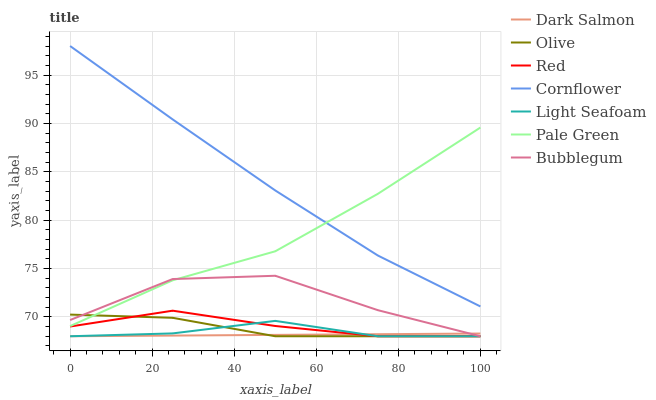Does Dark Salmon have the minimum area under the curve?
Answer yes or no. Yes. Does Cornflower have the maximum area under the curve?
Answer yes or no. Yes. Does Bubblegum have the minimum area under the curve?
Answer yes or no. No. Does Bubblegum have the maximum area under the curve?
Answer yes or no. No. Is Dark Salmon the smoothest?
Answer yes or no. Yes. Is Bubblegum the roughest?
Answer yes or no. Yes. Is Bubblegum the smoothest?
Answer yes or no. No. Is Dark Salmon the roughest?
Answer yes or no. No. Does Dark Salmon have the lowest value?
Answer yes or no. Yes. Does Pale Green have the lowest value?
Answer yes or no. No. Does Cornflower have the highest value?
Answer yes or no. Yes. Does Bubblegum have the highest value?
Answer yes or no. No. Is Light Seafoam less than Cornflower?
Answer yes or no. Yes. Is Cornflower greater than Light Seafoam?
Answer yes or no. Yes. Does Dark Salmon intersect Olive?
Answer yes or no. Yes. Is Dark Salmon less than Olive?
Answer yes or no. No. Is Dark Salmon greater than Olive?
Answer yes or no. No. Does Light Seafoam intersect Cornflower?
Answer yes or no. No. 